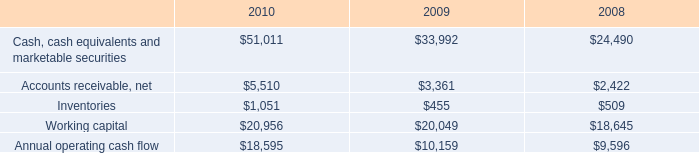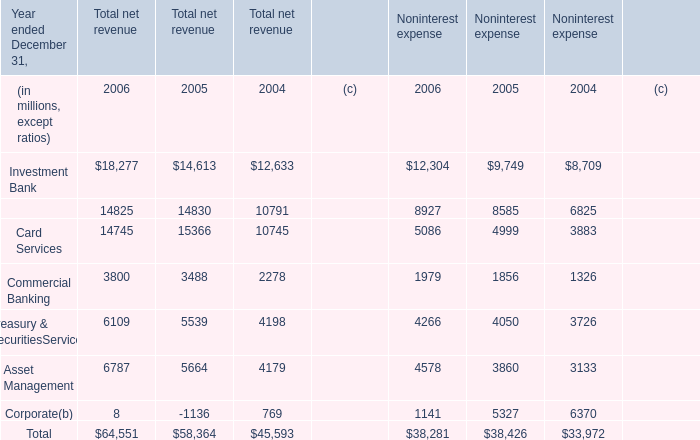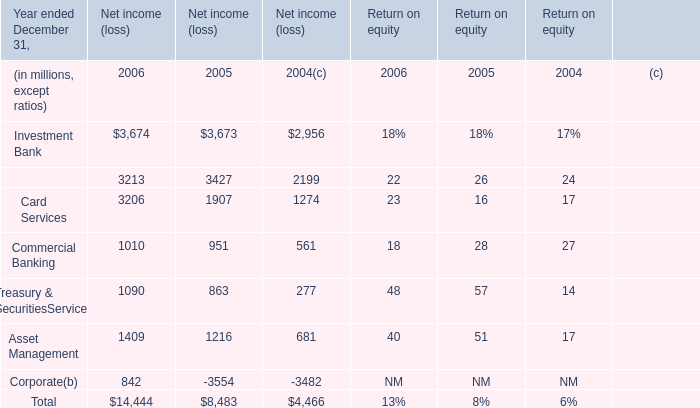What was the average value of the Retail Financial Services in the years where Investment Bank is positive for Net income (loss)? (in million) 
Computations: (((3213 + 3427) + 2199) / 3)
Answer: 2946.33333. 